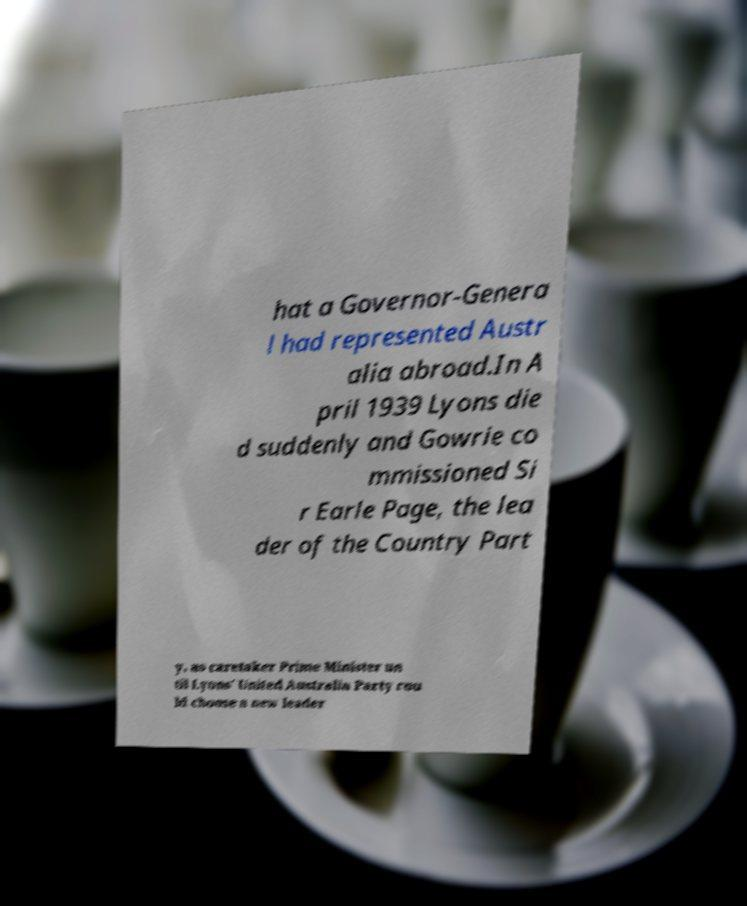Can you read and provide the text displayed in the image?This photo seems to have some interesting text. Can you extract and type it out for me? hat a Governor-Genera l had represented Austr alia abroad.In A pril 1939 Lyons die d suddenly and Gowrie co mmissioned Si r Earle Page, the lea der of the Country Part y, as caretaker Prime Minister un til Lyons' United Australia Party cou ld choose a new leader 